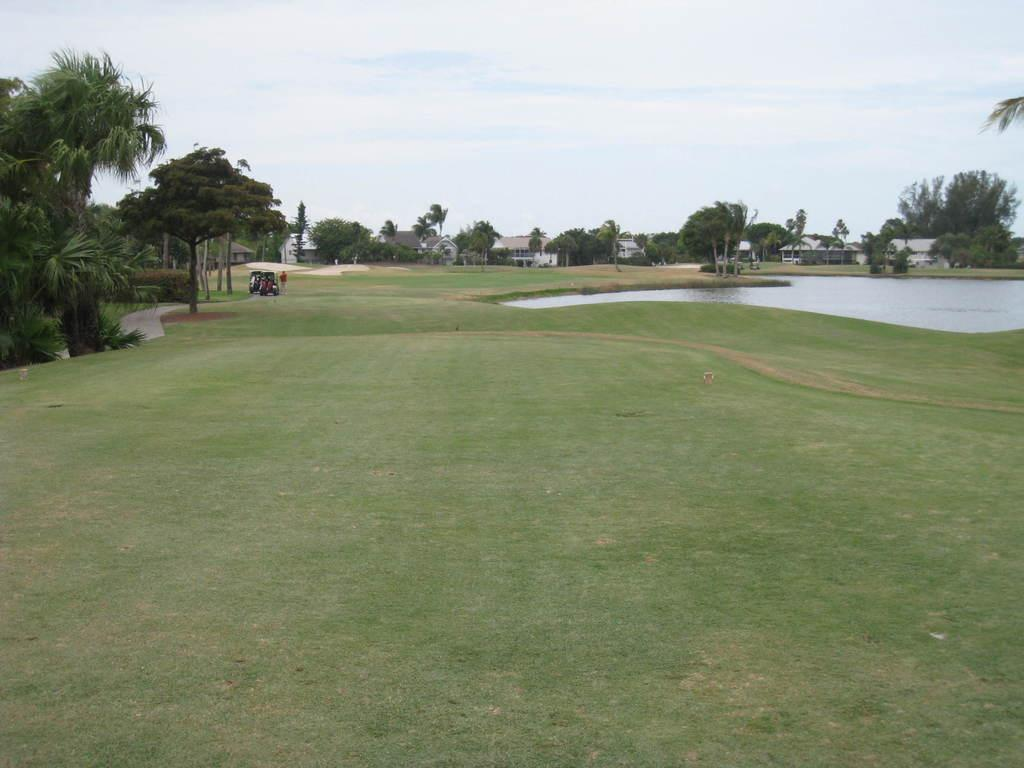What type of natural environment is visible in the image? There is grass, water, and trees visible in the image. What type of man-made structures can be seen in the image? There are buildings in the image. What part of the natural environment is visible in the image? The sky is visible in the image. Can you describe the person in the image? There is a person standing in the image. What type of transportation is present in the image? There is a vehicle in the image. What level of interest does the person in the image have in the measurement of pain? There is no information about the person's interest in measuring pain in the image. 